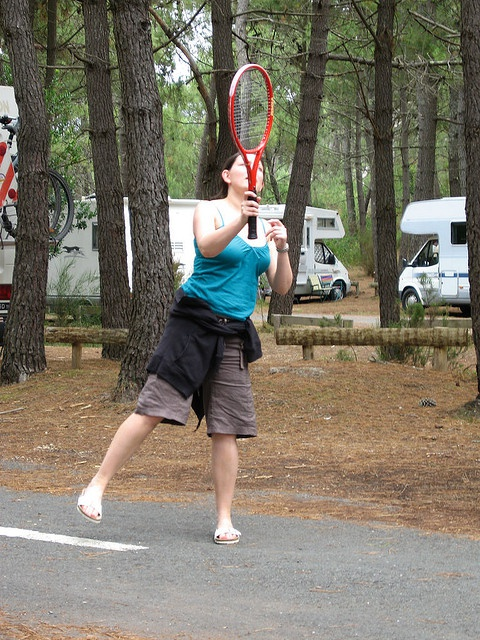Describe the objects in this image and their specific colors. I can see people in black, white, gray, and tan tones, truck in black, white, darkgray, and gray tones, truck in black, lightgray, gray, and darkgray tones, tennis racket in black, darkgray, gray, and white tones, and bicycle in black, gray, darkgray, and lightgray tones in this image. 